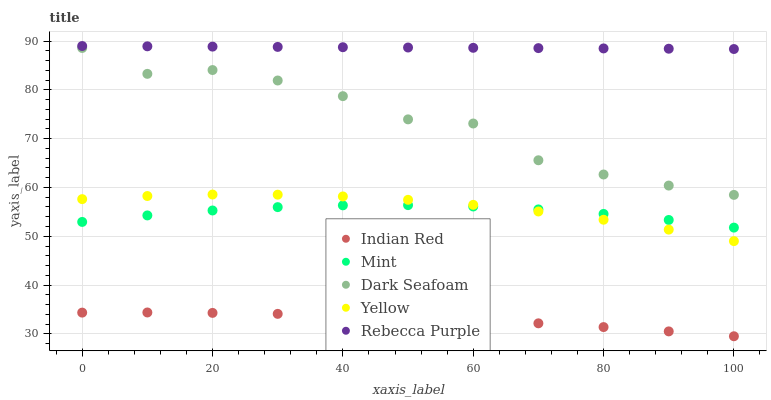Does Indian Red have the minimum area under the curve?
Answer yes or no. Yes. Does Rebecca Purple have the maximum area under the curve?
Answer yes or no. Yes. Does Mint have the minimum area under the curve?
Answer yes or no. No. Does Mint have the maximum area under the curve?
Answer yes or no. No. Is Rebecca Purple the smoothest?
Answer yes or no. Yes. Is Dark Seafoam the roughest?
Answer yes or no. Yes. Is Mint the smoothest?
Answer yes or no. No. Is Mint the roughest?
Answer yes or no. No. Does Indian Red have the lowest value?
Answer yes or no. Yes. Does Mint have the lowest value?
Answer yes or no. No. Does Rebecca Purple have the highest value?
Answer yes or no. Yes. Does Mint have the highest value?
Answer yes or no. No. Is Indian Red less than Mint?
Answer yes or no. Yes. Is Rebecca Purple greater than Yellow?
Answer yes or no. Yes. Does Mint intersect Yellow?
Answer yes or no. Yes. Is Mint less than Yellow?
Answer yes or no. No. Is Mint greater than Yellow?
Answer yes or no. No. Does Indian Red intersect Mint?
Answer yes or no. No. 